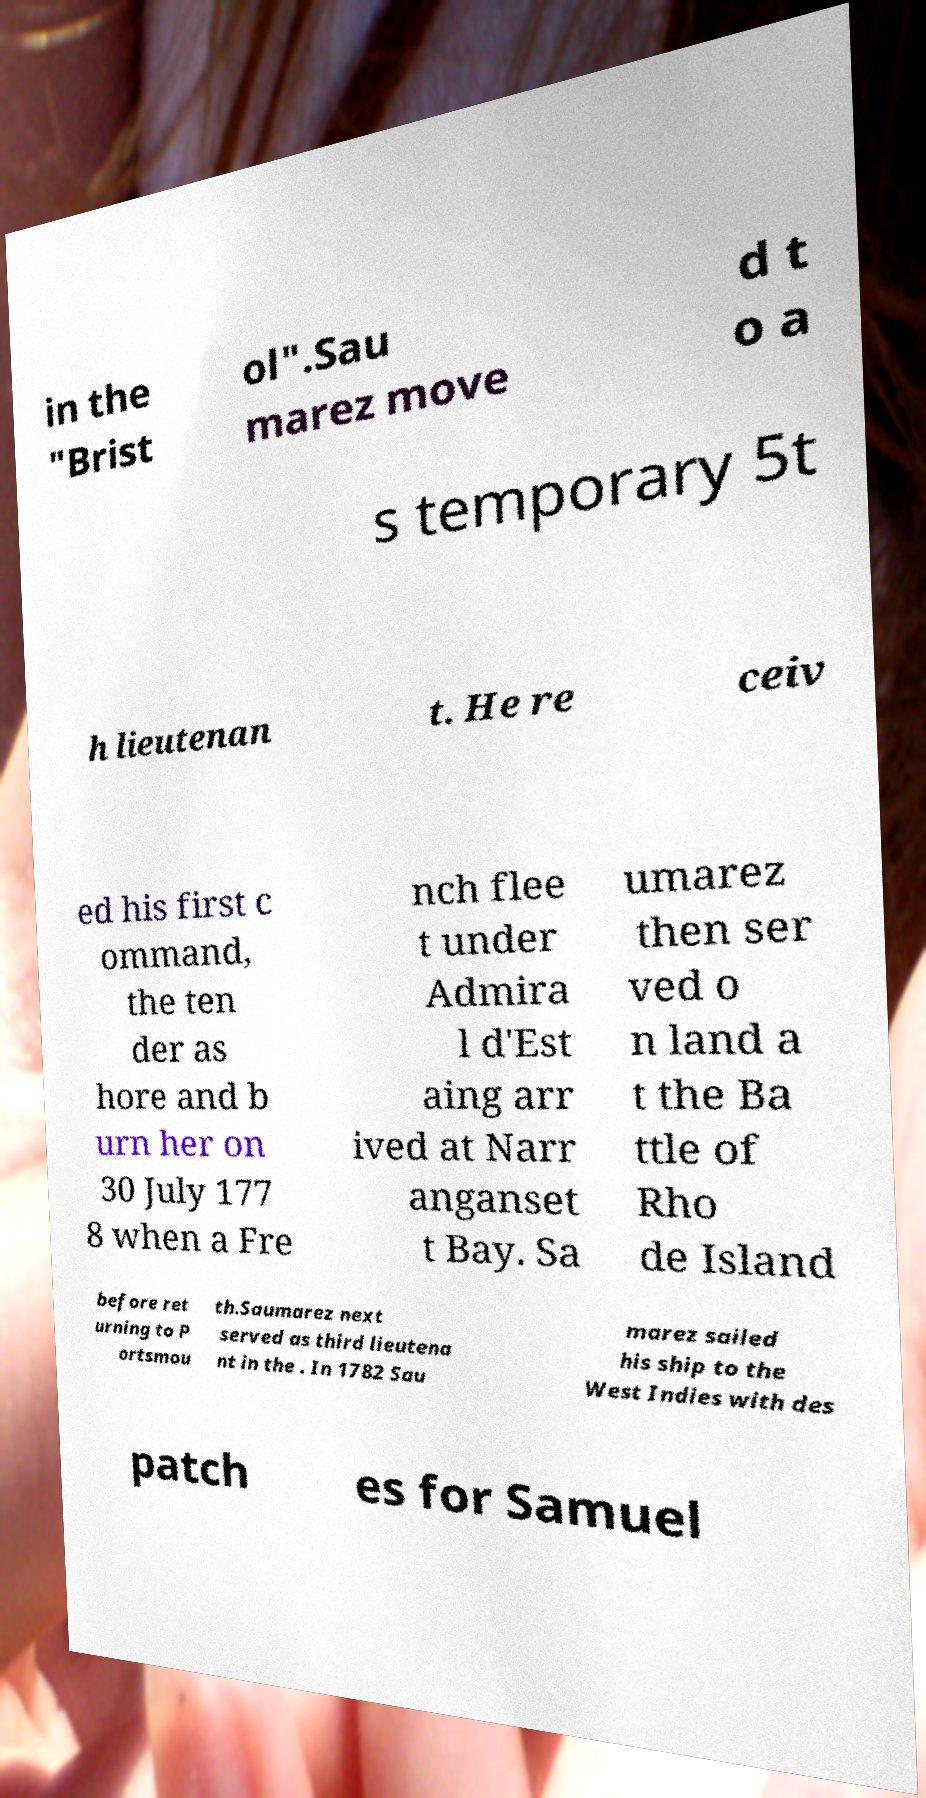I need the written content from this picture converted into text. Can you do that? in the "Brist ol".Sau marez move d t o a s temporary 5t h lieutenan t. He re ceiv ed his first c ommand, the ten der as hore and b urn her on 30 July 177 8 when a Fre nch flee t under Admira l d'Est aing arr ived at Narr anganset t Bay. Sa umarez then ser ved o n land a t the Ba ttle of Rho de Island before ret urning to P ortsmou th.Saumarez next served as third lieutena nt in the . In 1782 Sau marez sailed his ship to the West Indies with des patch es for Samuel 